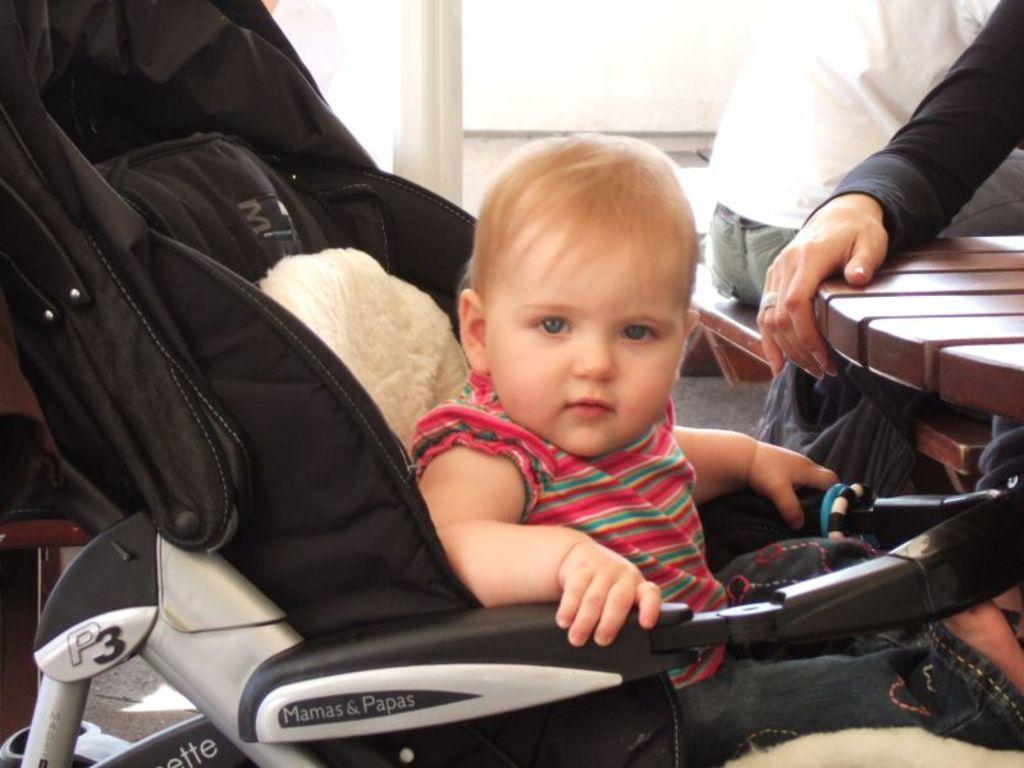What is the main subject of the image? There is a baby in the center of the image. What is the baby sitting on? The baby is in a chair. What can be seen in the background of the image? There are tables, persons, and a wall in the background of the image. What type of kite is the baby flying in the image? There is no kite present in the image; the baby is sitting in a chair. Can you tell me if the lake is visible in the image? There is no lake present in the image. 